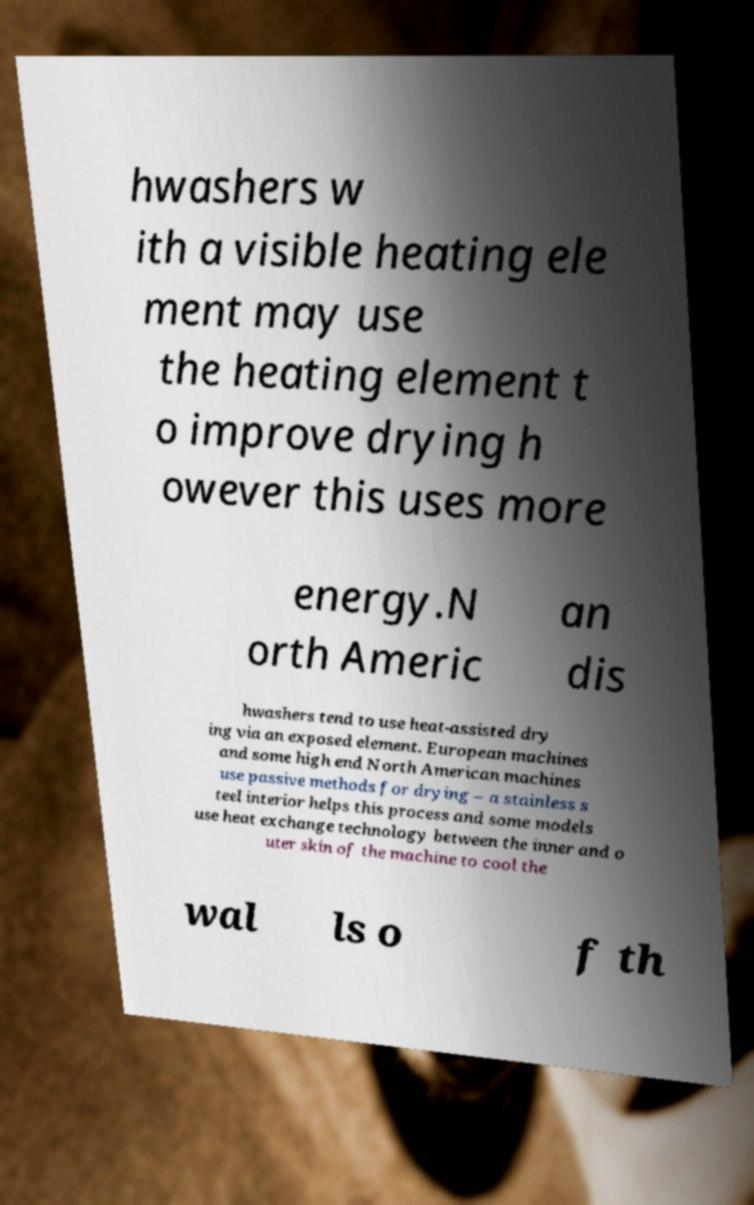Can you accurately transcribe the text from the provided image for me? hwashers w ith a visible heating ele ment may use the heating element t o improve drying h owever this uses more energy.N orth Americ an dis hwashers tend to use heat-assisted dry ing via an exposed element. European machines and some high end North American machines use passive methods for drying – a stainless s teel interior helps this process and some models use heat exchange technology between the inner and o uter skin of the machine to cool the wal ls o f th 